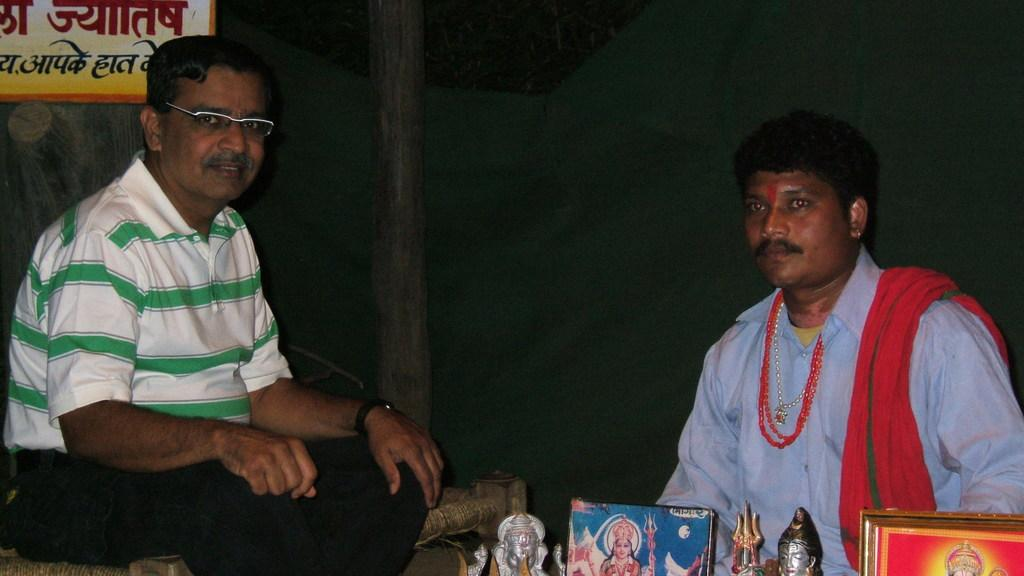How many people are in the image? There are two persons in the image. What else can be seen in the image besides the people? There are statues, frames, and a board in the image. Can you describe the board in the image? The board is a flat surface with writing or images on it. What is the color of the background in the image? The background of the image is dark. How many legs can be seen on the chin in the image? There is no chin present in the image, and therefore no legs can be seen on it. 